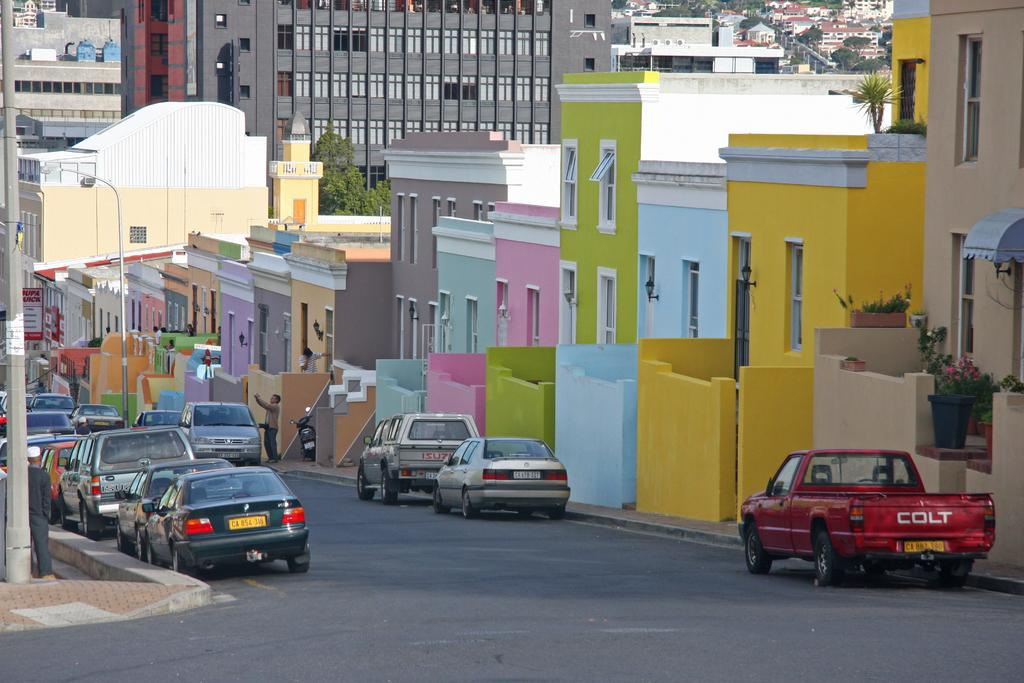Provide a one-sentence caption for the provided image. Brightly colored stuco houses on a street with cars and the last one is a Colt. 